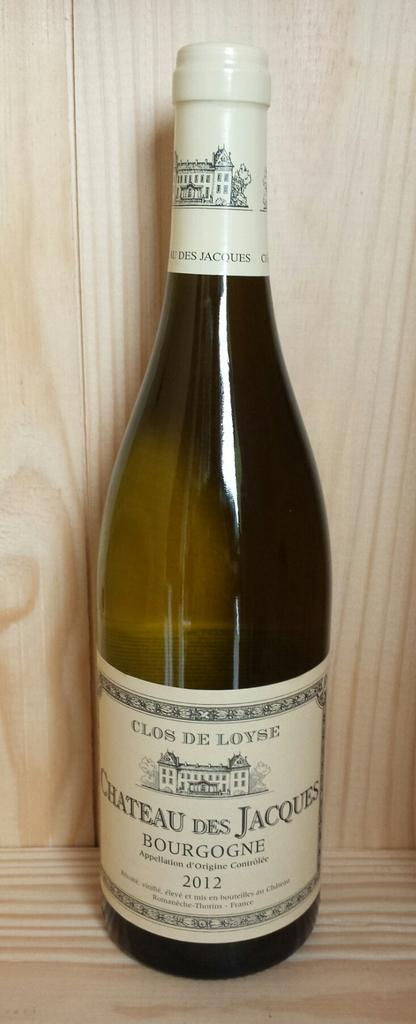<image>
Create a compact narrative representing the image presented. the word chateau that is on a wine bottle 